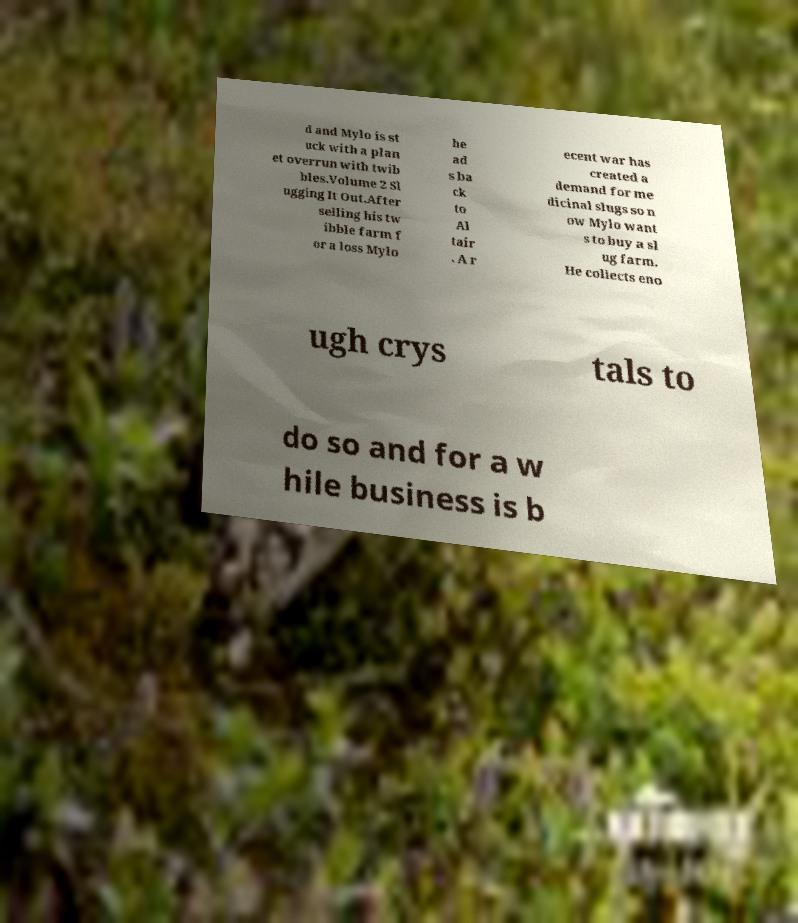Could you extract and type out the text from this image? d and Mylo is st uck with a plan et overrun with twib bles.Volume 2 Sl ugging It Out.After selling his tw ibble farm f or a loss Mylo he ad s ba ck to Al tair . A r ecent war has created a demand for me dicinal slugs so n ow Mylo want s to buy a sl ug farm. He collects eno ugh crys tals to do so and for a w hile business is b 